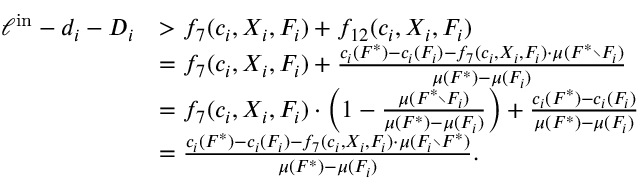Convert formula to latex. <formula><loc_0><loc_0><loc_500><loc_500>\begin{array} { r l } { \ell ^ { i n } - d _ { i } - D _ { i } } & { > f _ { 7 } ( c _ { i } , X _ { i } , F _ { i } ) + f _ { 1 2 } ( c _ { i } , X _ { i } , F _ { i } ) } & { = f _ { 7 } ( c _ { i } , X _ { i } , F _ { i } ) + \frac { c _ { i } ( F ^ { * } ) - c _ { i } ( F _ { i } ) - f _ { 7 } ( c _ { i } , X _ { i } , F _ { i } ) \cdot \mu ( F ^ { * } \ F _ { i } ) } { \mu ( F ^ { * } ) - \mu ( F _ { i } ) } } & { = f _ { 7 } ( c _ { i } , X _ { i } , F _ { i } ) \cdot \left ( 1 - \frac { \mu ( F ^ { * } \ F _ { i } ) } { \mu ( F ^ { * } ) - \mu ( F _ { i } ) } \right ) + \frac { c _ { i } ( F ^ { * } ) - c _ { i } ( F _ { i } ) } { \mu ( F ^ { * } ) - \mu ( F _ { i } ) } } & { = \frac { c _ { i } ( F ^ { * } ) - c _ { i } ( F _ { i } ) - f _ { 7 } ( c _ { i } , X _ { i } , F _ { i } ) \cdot \mu ( F _ { i } \ F ^ { * } ) } { \mu ( F ^ { * } ) - \mu ( F _ { i } ) } . } \end{array}</formula> 